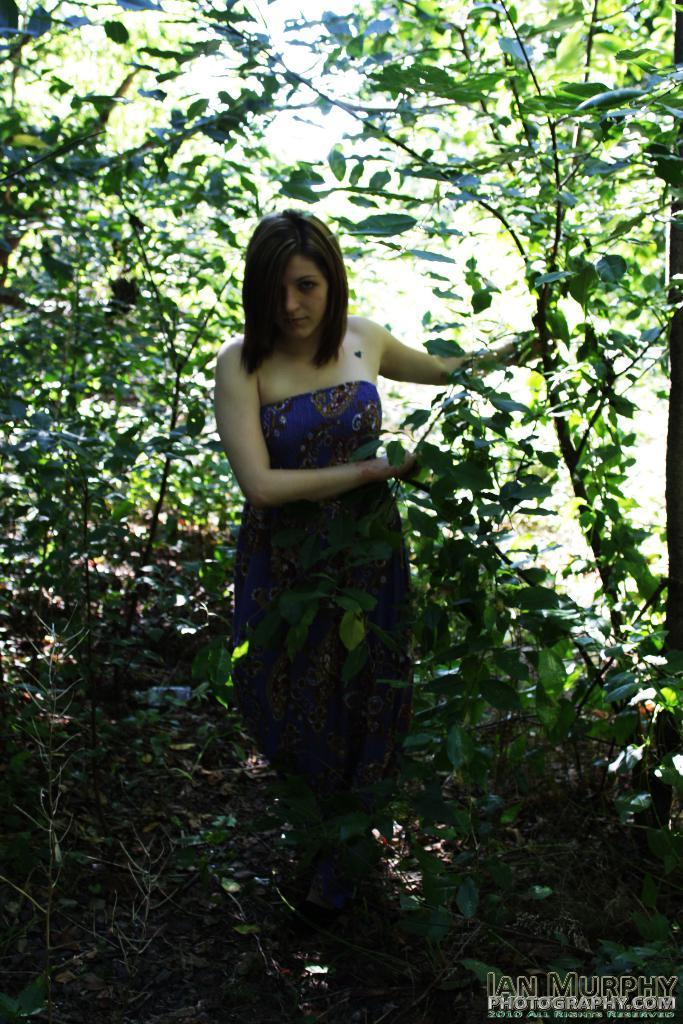What is the lady holding in the image? The lady is holding a tree in the image. What can be seen in the background of the image? There are many trees in the background of the image. Is there any additional information or marking in the image? Yes, there is a watermark in the right corner of the image. Are there any fairies flying around the trees in the image? There is no mention of fairies in the image, so we cannot confirm their presence. 